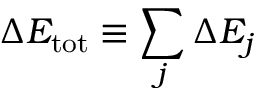Convert formula to latex. <formula><loc_0><loc_0><loc_500><loc_500>\Delta E _ { t o t } \equiv \sum _ { j } \Delta E _ { j }</formula> 